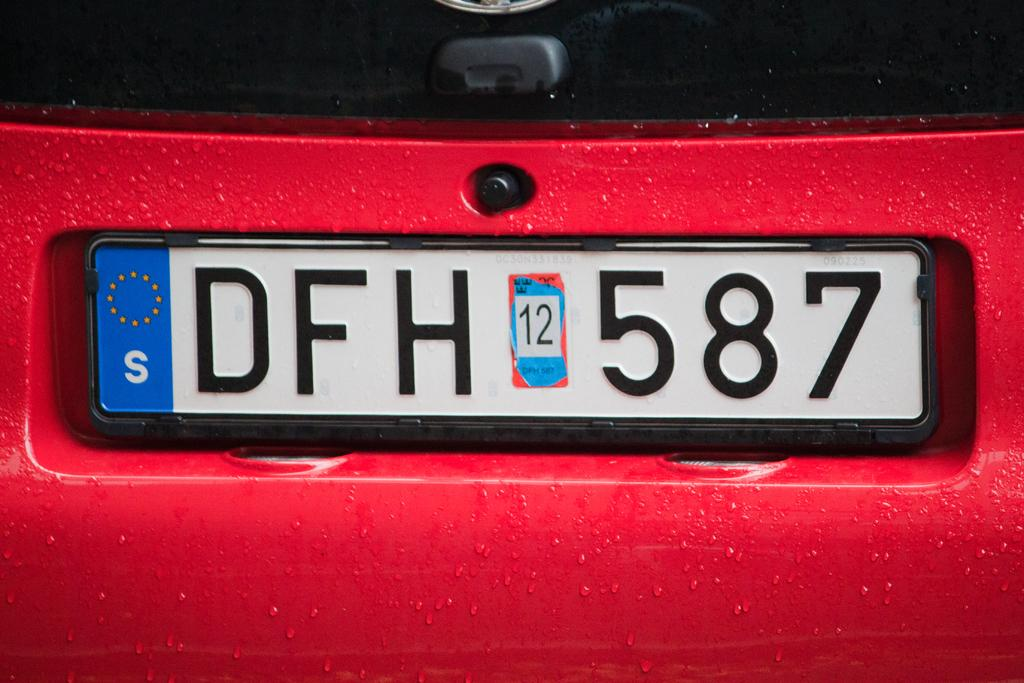<image>
Provide a brief description of the given image. a license plate on a red car displaying the tag DFH 587 